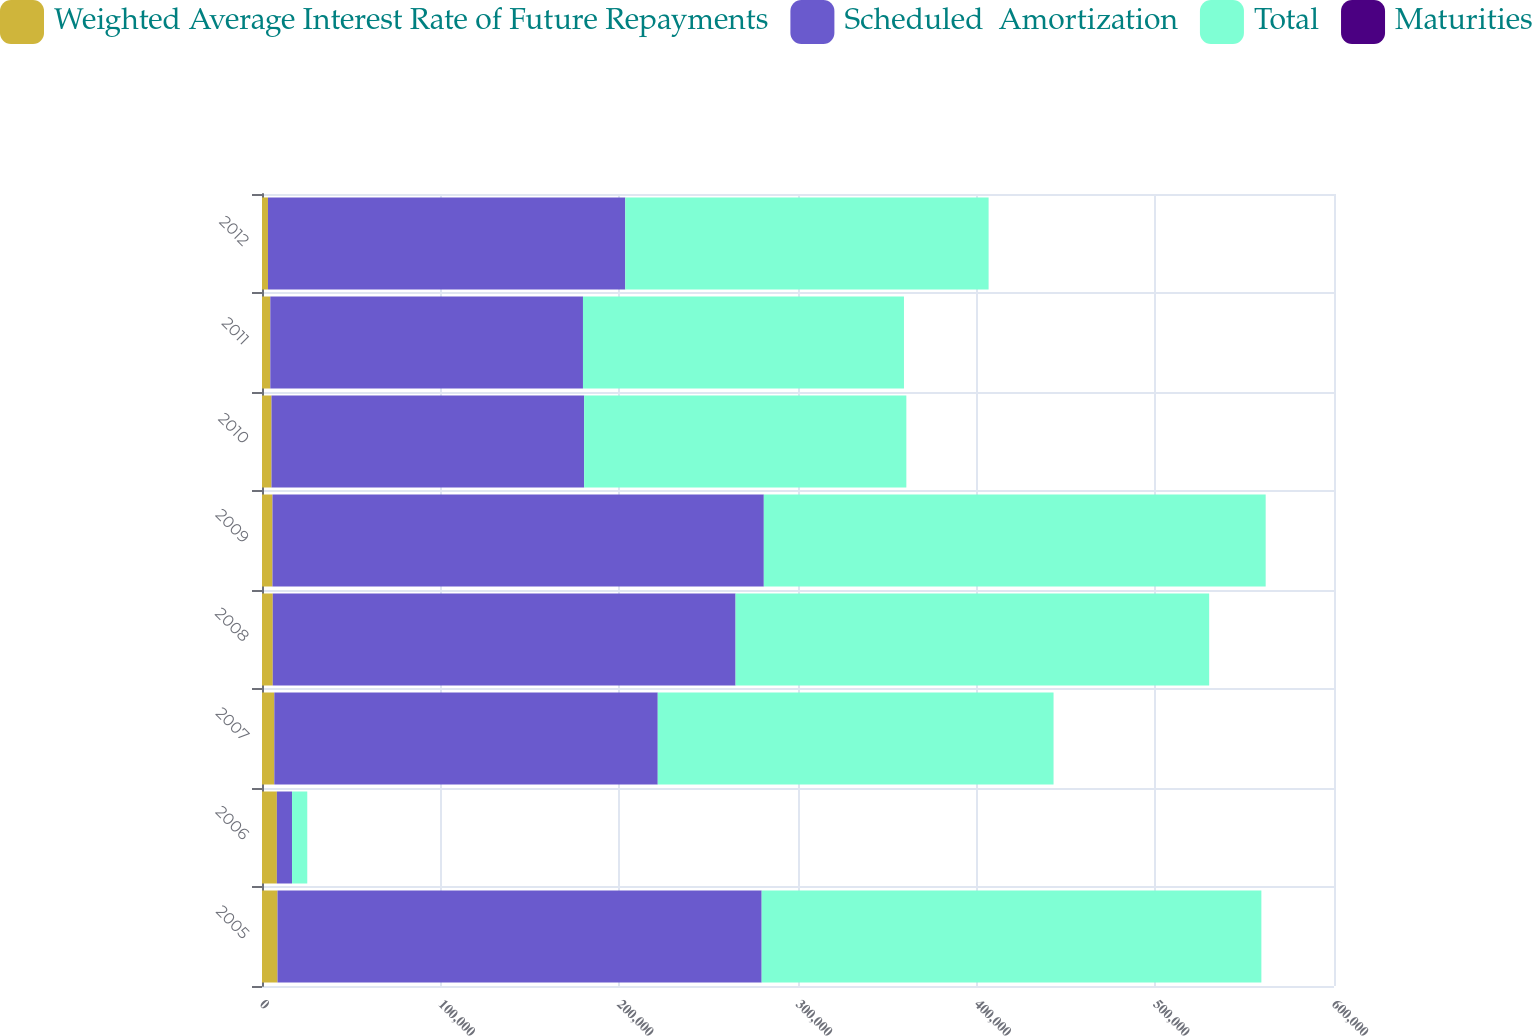<chart> <loc_0><loc_0><loc_500><loc_500><stacked_bar_chart><ecel><fcel>2005<fcel>2006<fcel>2007<fcel>2008<fcel>2009<fcel>2010<fcel>2011<fcel>2012<nl><fcel>Weighted Average Interest Rate of Future Repayments<fcel>8686<fcel>8318<fcel>6891<fcel>6031<fcel>5867<fcel>5313<fcel>4647<fcel>3332<nl><fcel>Scheduled  Amortization<fcel>270980<fcel>8502<fcel>214615<fcel>259028<fcel>275000<fcel>175000<fcel>175000<fcel>200000<nl><fcel>Total<fcel>279666<fcel>8502<fcel>221506<fcel>265059<fcel>280867<fcel>180313<fcel>179647<fcel>203332<nl><fcel>Maturities<fcel>6.04<fcel>4.29<fcel>5.51<fcel>4.92<fcel>7.37<fcel>5.39<fcel>6.94<fcel>5.86<nl></chart> 